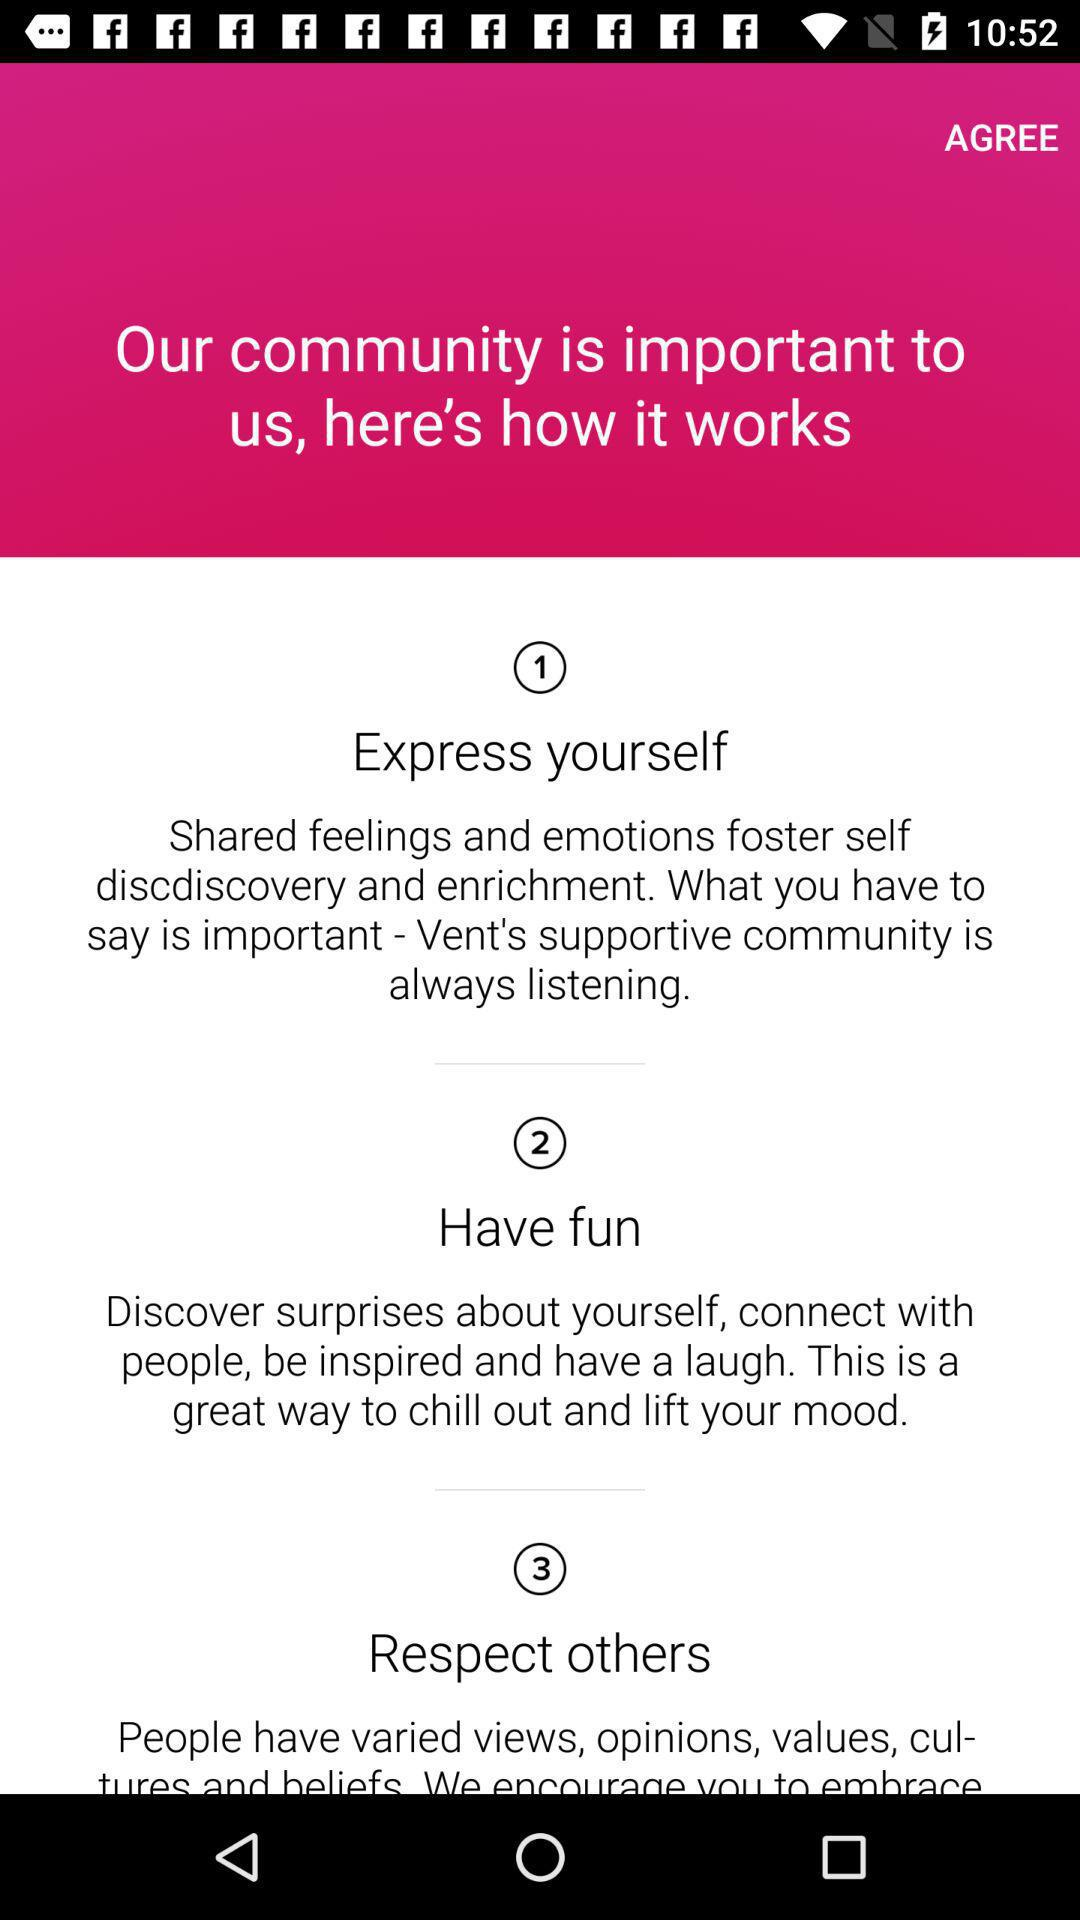"Respect others" comes under what point? "Respect others" comes under point number 3. 